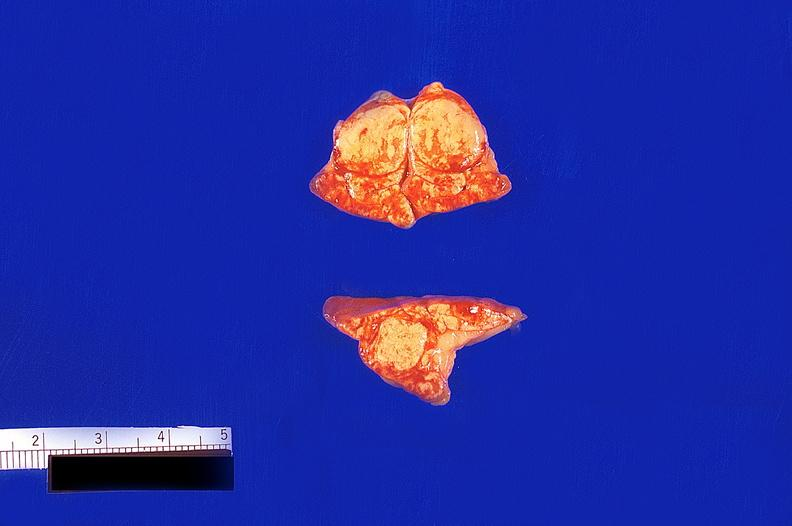what does this image show?
Answer the question using a single word or phrase. Adrenal gland 